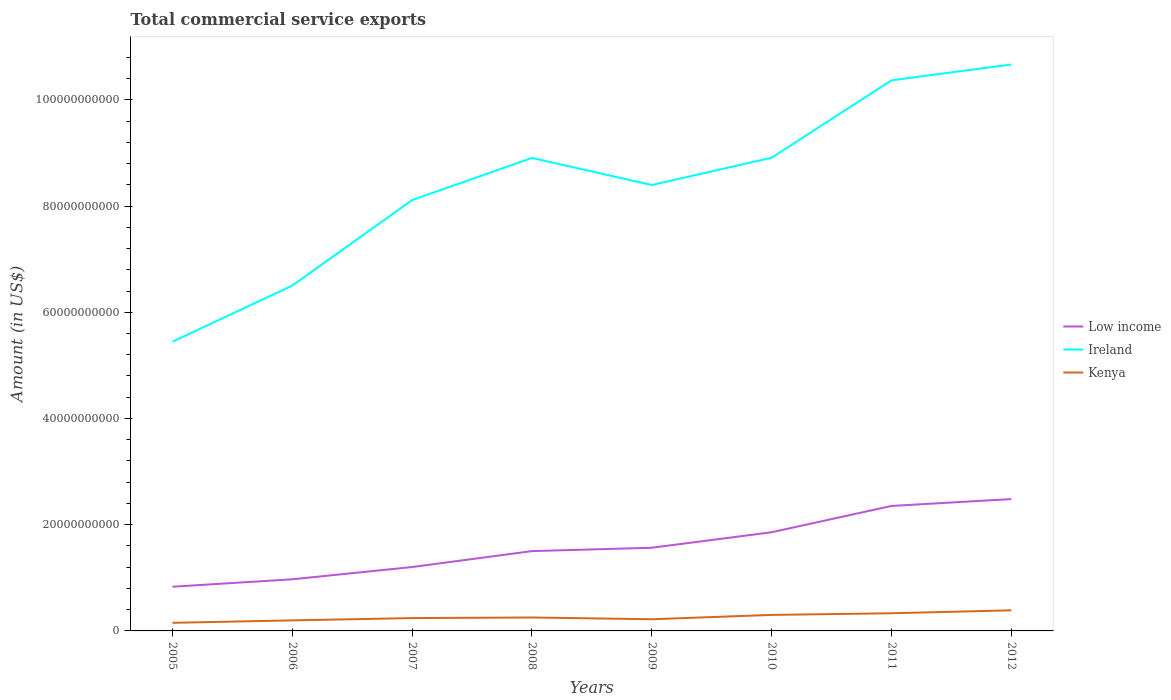Is the number of lines equal to the number of legend labels?
Your response must be concise. Yes. Across all years, what is the maximum total commercial service exports in Ireland?
Your answer should be very brief. 5.45e+1. What is the total total commercial service exports in Kenya in the graph?
Provide a succinct answer. -1.35e+09. What is the difference between the highest and the second highest total commercial service exports in Kenya?
Ensure brevity in your answer.  2.35e+09. Is the total commercial service exports in Low income strictly greater than the total commercial service exports in Ireland over the years?
Provide a succinct answer. Yes. How many lines are there?
Offer a very short reply. 3. What is the difference between two consecutive major ticks on the Y-axis?
Your answer should be very brief. 2.00e+1. Are the values on the major ticks of Y-axis written in scientific E-notation?
Provide a short and direct response. No. Does the graph contain any zero values?
Offer a terse response. No. Does the graph contain grids?
Your answer should be compact. No. Where does the legend appear in the graph?
Provide a succinct answer. Center right. What is the title of the graph?
Offer a terse response. Total commercial service exports. What is the Amount (in US$) of Low income in 2005?
Give a very brief answer. 8.32e+09. What is the Amount (in US$) of Ireland in 2005?
Your response must be concise. 5.45e+1. What is the Amount (in US$) of Kenya in 2005?
Make the answer very short. 1.53e+09. What is the Amount (in US$) of Low income in 2006?
Make the answer very short. 9.72e+09. What is the Amount (in US$) in Ireland in 2006?
Provide a succinct answer. 6.50e+1. What is the Amount (in US$) of Kenya in 2006?
Your answer should be compact. 1.99e+09. What is the Amount (in US$) in Low income in 2007?
Your answer should be compact. 1.20e+1. What is the Amount (in US$) of Ireland in 2007?
Your response must be concise. 8.11e+1. What is the Amount (in US$) in Kenya in 2007?
Make the answer very short. 2.42e+09. What is the Amount (in US$) in Low income in 2008?
Provide a short and direct response. 1.50e+1. What is the Amount (in US$) of Ireland in 2008?
Your answer should be very brief. 8.91e+1. What is the Amount (in US$) in Kenya in 2008?
Your answer should be compact. 2.53e+09. What is the Amount (in US$) in Low income in 2009?
Ensure brevity in your answer.  1.57e+1. What is the Amount (in US$) of Ireland in 2009?
Ensure brevity in your answer.  8.40e+1. What is the Amount (in US$) in Kenya in 2009?
Ensure brevity in your answer.  2.20e+09. What is the Amount (in US$) in Low income in 2010?
Offer a very short reply. 1.86e+1. What is the Amount (in US$) in Ireland in 2010?
Ensure brevity in your answer.  8.91e+1. What is the Amount (in US$) in Kenya in 2010?
Provide a succinct answer. 3.02e+09. What is the Amount (in US$) of Low income in 2011?
Provide a short and direct response. 2.35e+1. What is the Amount (in US$) in Ireland in 2011?
Your response must be concise. 1.04e+11. What is the Amount (in US$) in Kenya in 2011?
Offer a terse response. 3.33e+09. What is the Amount (in US$) of Low income in 2012?
Make the answer very short. 2.48e+1. What is the Amount (in US$) of Ireland in 2012?
Ensure brevity in your answer.  1.07e+11. What is the Amount (in US$) in Kenya in 2012?
Make the answer very short. 3.88e+09. Across all years, what is the maximum Amount (in US$) of Low income?
Make the answer very short. 2.48e+1. Across all years, what is the maximum Amount (in US$) of Ireland?
Your answer should be compact. 1.07e+11. Across all years, what is the maximum Amount (in US$) of Kenya?
Give a very brief answer. 3.88e+09. Across all years, what is the minimum Amount (in US$) in Low income?
Provide a short and direct response. 8.32e+09. Across all years, what is the minimum Amount (in US$) in Ireland?
Offer a very short reply. 5.45e+1. Across all years, what is the minimum Amount (in US$) in Kenya?
Provide a succinct answer. 1.53e+09. What is the total Amount (in US$) in Low income in the graph?
Your answer should be very brief. 1.28e+11. What is the total Amount (in US$) in Ireland in the graph?
Your answer should be very brief. 6.73e+11. What is the total Amount (in US$) of Kenya in the graph?
Your answer should be very brief. 2.09e+1. What is the difference between the Amount (in US$) of Low income in 2005 and that in 2006?
Provide a succinct answer. -1.40e+09. What is the difference between the Amount (in US$) in Ireland in 2005 and that in 2006?
Keep it short and to the point. -1.06e+1. What is the difference between the Amount (in US$) in Kenya in 2005 and that in 2006?
Ensure brevity in your answer.  -4.61e+08. What is the difference between the Amount (in US$) of Low income in 2005 and that in 2007?
Give a very brief answer. -3.71e+09. What is the difference between the Amount (in US$) in Ireland in 2005 and that in 2007?
Your answer should be very brief. -2.67e+1. What is the difference between the Amount (in US$) in Kenya in 2005 and that in 2007?
Your answer should be very brief. -8.92e+08. What is the difference between the Amount (in US$) in Low income in 2005 and that in 2008?
Your answer should be compact. -6.71e+09. What is the difference between the Amount (in US$) of Ireland in 2005 and that in 2008?
Ensure brevity in your answer.  -3.46e+1. What is the difference between the Amount (in US$) in Kenya in 2005 and that in 2008?
Keep it short and to the point. -1.01e+09. What is the difference between the Amount (in US$) of Low income in 2005 and that in 2009?
Your answer should be compact. -7.34e+09. What is the difference between the Amount (in US$) of Ireland in 2005 and that in 2009?
Provide a succinct answer. -2.95e+1. What is the difference between the Amount (in US$) in Kenya in 2005 and that in 2009?
Keep it short and to the point. -6.73e+08. What is the difference between the Amount (in US$) in Low income in 2005 and that in 2010?
Keep it short and to the point. -1.03e+1. What is the difference between the Amount (in US$) in Ireland in 2005 and that in 2010?
Ensure brevity in your answer.  -3.46e+1. What is the difference between the Amount (in US$) of Kenya in 2005 and that in 2010?
Offer a terse response. -1.49e+09. What is the difference between the Amount (in US$) in Low income in 2005 and that in 2011?
Provide a succinct answer. -1.52e+1. What is the difference between the Amount (in US$) of Ireland in 2005 and that in 2011?
Ensure brevity in your answer.  -4.92e+1. What is the difference between the Amount (in US$) of Kenya in 2005 and that in 2011?
Give a very brief answer. -1.80e+09. What is the difference between the Amount (in US$) of Low income in 2005 and that in 2012?
Keep it short and to the point. -1.65e+1. What is the difference between the Amount (in US$) of Ireland in 2005 and that in 2012?
Provide a succinct answer. -5.22e+1. What is the difference between the Amount (in US$) in Kenya in 2005 and that in 2012?
Provide a succinct answer. -2.35e+09. What is the difference between the Amount (in US$) in Low income in 2006 and that in 2007?
Make the answer very short. -2.31e+09. What is the difference between the Amount (in US$) in Ireland in 2006 and that in 2007?
Provide a succinct answer. -1.61e+1. What is the difference between the Amount (in US$) in Kenya in 2006 and that in 2007?
Provide a succinct answer. -4.31e+08. What is the difference between the Amount (in US$) in Low income in 2006 and that in 2008?
Your answer should be compact. -5.31e+09. What is the difference between the Amount (in US$) in Ireland in 2006 and that in 2008?
Your response must be concise. -2.40e+1. What is the difference between the Amount (in US$) of Kenya in 2006 and that in 2008?
Your answer should be compact. -5.44e+08. What is the difference between the Amount (in US$) in Low income in 2006 and that in 2009?
Give a very brief answer. -5.94e+09. What is the difference between the Amount (in US$) in Ireland in 2006 and that in 2009?
Make the answer very short. -1.89e+1. What is the difference between the Amount (in US$) of Kenya in 2006 and that in 2009?
Provide a succinct answer. -2.11e+08. What is the difference between the Amount (in US$) in Low income in 2006 and that in 2010?
Provide a short and direct response. -8.86e+09. What is the difference between the Amount (in US$) in Ireland in 2006 and that in 2010?
Make the answer very short. -2.41e+1. What is the difference between the Amount (in US$) in Kenya in 2006 and that in 2010?
Offer a very short reply. -1.03e+09. What is the difference between the Amount (in US$) in Low income in 2006 and that in 2011?
Give a very brief answer. -1.38e+1. What is the difference between the Amount (in US$) in Ireland in 2006 and that in 2011?
Offer a very short reply. -3.86e+1. What is the difference between the Amount (in US$) of Kenya in 2006 and that in 2011?
Your response must be concise. -1.34e+09. What is the difference between the Amount (in US$) in Low income in 2006 and that in 2012?
Ensure brevity in your answer.  -1.51e+1. What is the difference between the Amount (in US$) in Ireland in 2006 and that in 2012?
Make the answer very short. -4.16e+1. What is the difference between the Amount (in US$) of Kenya in 2006 and that in 2012?
Ensure brevity in your answer.  -1.89e+09. What is the difference between the Amount (in US$) of Low income in 2007 and that in 2008?
Your response must be concise. -3.00e+09. What is the difference between the Amount (in US$) of Ireland in 2007 and that in 2008?
Your response must be concise. -7.94e+09. What is the difference between the Amount (in US$) in Kenya in 2007 and that in 2008?
Your response must be concise. -1.13e+08. What is the difference between the Amount (in US$) of Low income in 2007 and that in 2009?
Offer a very short reply. -3.63e+09. What is the difference between the Amount (in US$) in Ireland in 2007 and that in 2009?
Offer a very short reply. -2.84e+09. What is the difference between the Amount (in US$) of Kenya in 2007 and that in 2009?
Offer a terse response. 2.20e+08. What is the difference between the Amount (in US$) in Low income in 2007 and that in 2010?
Your answer should be compact. -6.55e+09. What is the difference between the Amount (in US$) in Ireland in 2007 and that in 2010?
Make the answer very short. -7.97e+09. What is the difference between the Amount (in US$) in Kenya in 2007 and that in 2010?
Your answer should be very brief. -5.99e+08. What is the difference between the Amount (in US$) in Low income in 2007 and that in 2011?
Your response must be concise. -1.15e+1. What is the difference between the Amount (in US$) of Ireland in 2007 and that in 2011?
Provide a short and direct response. -2.26e+1. What is the difference between the Amount (in US$) in Kenya in 2007 and that in 2011?
Your answer should be compact. -9.08e+08. What is the difference between the Amount (in US$) of Low income in 2007 and that in 2012?
Offer a very short reply. -1.28e+1. What is the difference between the Amount (in US$) in Ireland in 2007 and that in 2012?
Keep it short and to the point. -2.55e+1. What is the difference between the Amount (in US$) of Kenya in 2007 and that in 2012?
Your answer should be compact. -1.46e+09. What is the difference between the Amount (in US$) in Low income in 2008 and that in 2009?
Give a very brief answer. -6.33e+08. What is the difference between the Amount (in US$) of Ireland in 2008 and that in 2009?
Keep it short and to the point. 5.10e+09. What is the difference between the Amount (in US$) in Kenya in 2008 and that in 2009?
Offer a terse response. 3.33e+08. What is the difference between the Amount (in US$) of Low income in 2008 and that in 2010?
Provide a short and direct response. -3.55e+09. What is the difference between the Amount (in US$) of Ireland in 2008 and that in 2010?
Make the answer very short. -3.44e+07. What is the difference between the Amount (in US$) of Kenya in 2008 and that in 2010?
Offer a very short reply. -4.85e+08. What is the difference between the Amount (in US$) in Low income in 2008 and that in 2011?
Your answer should be very brief. -8.50e+09. What is the difference between the Amount (in US$) of Ireland in 2008 and that in 2011?
Provide a short and direct response. -1.46e+1. What is the difference between the Amount (in US$) of Kenya in 2008 and that in 2011?
Provide a succinct answer. -7.95e+08. What is the difference between the Amount (in US$) in Low income in 2008 and that in 2012?
Ensure brevity in your answer.  -9.80e+09. What is the difference between the Amount (in US$) in Ireland in 2008 and that in 2012?
Keep it short and to the point. -1.76e+1. What is the difference between the Amount (in US$) in Kenya in 2008 and that in 2012?
Your answer should be compact. -1.35e+09. What is the difference between the Amount (in US$) in Low income in 2009 and that in 2010?
Your answer should be compact. -2.92e+09. What is the difference between the Amount (in US$) of Ireland in 2009 and that in 2010?
Provide a succinct answer. -5.14e+09. What is the difference between the Amount (in US$) in Kenya in 2009 and that in 2010?
Your answer should be compact. -8.18e+08. What is the difference between the Amount (in US$) in Low income in 2009 and that in 2011?
Make the answer very short. -7.87e+09. What is the difference between the Amount (in US$) of Ireland in 2009 and that in 2011?
Offer a very short reply. -1.97e+1. What is the difference between the Amount (in US$) in Kenya in 2009 and that in 2011?
Your response must be concise. -1.13e+09. What is the difference between the Amount (in US$) of Low income in 2009 and that in 2012?
Your answer should be very brief. -9.16e+09. What is the difference between the Amount (in US$) in Ireland in 2009 and that in 2012?
Give a very brief answer. -2.27e+1. What is the difference between the Amount (in US$) in Kenya in 2009 and that in 2012?
Your response must be concise. -1.68e+09. What is the difference between the Amount (in US$) of Low income in 2010 and that in 2011?
Give a very brief answer. -4.95e+09. What is the difference between the Amount (in US$) in Ireland in 2010 and that in 2011?
Make the answer very short. -1.46e+1. What is the difference between the Amount (in US$) of Kenya in 2010 and that in 2011?
Your answer should be very brief. -3.09e+08. What is the difference between the Amount (in US$) in Low income in 2010 and that in 2012?
Offer a terse response. -6.25e+09. What is the difference between the Amount (in US$) in Ireland in 2010 and that in 2012?
Keep it short and to the point. -1.76e+1. What is the difference between the Amount (in US$) of Kenya in 2010 and that in 2012?
Offer a very short reply. -8.64e+08. What is the difference between the Amount (in US$) of Low income in 2011 and that in 2012?
Your response must be concise. -1.29e+09. What is the difference between the Amount (in US$) of Ireland in 2011 and that in 2012?
Give a very brief answer. -2.98e+09. What is the difference between the Amount (in US$) in Kenya in 2011 and that in 2012?
Ensure brevity in your answer.  -5.54e+08. What is the difference between the Amount (in US$) of Low income in 2005 and the Amount (in US$) of Ireland in 2006?
Offer a very short reply. -5.67e+1. What is the difference between the Amount (in US$) in Low income in 2005 and the Amount (in US$) in Kenya in 2006?
Give a very brief answer. 6.34e+09. What is the difference between the Amount (in US$) in Ireland in 2005 and the Amount (in US$) in Kenya in 2006?
Make the answer very short. 5.25e+1. What is the difference between the Amount (in US$) of Low income in 2005 and the Amount (in US$) of Ireland in 2007?
Provide a succinct answer. -7.28e+1. What is the difference between the Amount (in US$) in Low income in 2005 and the Amount (in US$) in Kenya in 2007?
Your response must be concise. 5.90e+09. What is the difference between the Amount (in US$) in Ireland in 2005 and the Amount (in US$) in Kenya in 2007?
Make the answer very short. 5.20e+1. What is the difference between the Amount (in US$) of Low income in 2005 and the Amount (in US$) of Ireland in 2008?
Offer a very short reply. -8.07e+1. What is the difference between the Amount (in US$) of Low income in 2005 and the Amount (in US$) of Kenya in 2008?
Your answer should be very brief. 5.79e+09. What is the difference between the Amount (in US$) of Ireland in 2005 and the Amount (in US$) of Kenya in 2008?
Your answer should be very brief. 5.19e+1. What is the difference between the Amount (in US$) of Low income in 2005 and the Amount (in US$) of Ireland in 2009?
Your answer should be compact. -7.56e+1. What is the difference between the Amount (in US$) in Low income in 2005 and the Amount (in US$) in Kenya in 2009?
Keep it short and to the point. 6.12e+09. What is the difference between the Amount (in US$) of Ireland in 2005 and the Amount (in US$) of Kenya in 2009?
Give a very brief answer. 5.23e+1. What is the difference between the Amount (in US$) of Low income in 2005 and the Amount (in US$) of Ireland in 2010?
Provide a succinct answer. -8.08e+1. What is the difference between the Amount (in US$) of Low income in 2005 and the Amount (in US$) of Kenya in 2010?
Keep it short and to the point. 5.31e+09. What is the difference between the Amount (in US$) of Ireland in 2005 and the Amount (in US$) of Kenya in 2010?
Your response must be concise. 5.14e+1. What is the difference between the Amount (in US$) in Low income in 2005 and the Amount (in US$) in Ireland in 2011?
Keep it short and to the point. -9.54e+1. What is the difference between the Amount (in US$) in Low income in 2005 and the Amount (in US$) in Kenya in 2011?
Your answer should be compact. 5.00e+09. What is the difference between the Amount (in US$) of Ireland in 2005 and the Amount (in US$) of Kenya in 2011?
Your answer should be compact. 5.11e+1. What is the difference between the Amount (in US$) of Low income in 2005 and the Amount (in US$) of Ireland in 2012?
Keep it short and to the point. -9.83e+1. What is the difference between the Amount (in US$) in Low income in 2005 and the Amount (in US$) in Kenya in 2012?
Your response must be concise. 4.44e+09. What is the difference between the Amount (in US$) in Ireland in 2005 and the Amount (in US$) in Kenya in 2012?
Make the answer very short. 5.06e+1. What is the difference between the Amount (in US$) of Low income in 2006 and the Amount (in US$) of Ireland in 2007?
Provide a short and direct response. -7.14e+1. What is the difference between the Amount (in US$) of Low income in 2006 and the Amount (in US$) of Kenya in 2007?
Offer a terse response. 7.30e+09. What is the difference between the Amount (in US$) of Ireland in 2006 and the Amount (in US$) of Kenya in 2007?
Make the answer very short. 6.26e+1. What is the difference between the Amount (in US$) in Low income in 2006 and the Amount (in US$) in Ireland in 2008?
Give a very brief answer. -7.93e+1. What is the difference between the Amount (in US$) of Low income in 2006 and the Amount (in US$) of Kenya in 2008?
Provide a short and direct response. 7.19e+09. What is the difference between the Amount (in US$) in Ireland in 2006 and the Amount (in US$) in Kenya in 2008?
Ensure brevity in your answer.  6.25e+1. What is the difference between the Amount (in US$) of Low income in 2006 and the Amount (in US$) of Ireland in 2009?
Your answer should be very brief. -7.42e+1. What is the difference between the Amount (in US$) of Low income in 2006 and the Amount (in US$) of Kenya in 2009?
Your answer should be very brief. 7.52e+09. What is the difference between the Amount (in US$) of Ireland in 2006 and the Amount (in US$) of Kenya in 2009?
Keep it short and to the point. 6.28e+1. What is the difference between the Amount (in US$) of Low income in 2006 and the Amount (in US$) of Ireland in 2010?
Ensure brevity in your answer.  -7.94e+1. What is the difference between the Amount (in US$) of Low income in 2006 and the Amount (in US$) of Kenya in 2010?
Make the answer very short. 6.70e+09. What is the difference between the Amount (in US$) of Ireland in 2006 and the Amount (in US$) of Kenya in 2010?
Ensure brevity in your answer.  6.20e+1. What is the difference between the Amount (in US$) of Low income in 2006 and the Amount (in US$) of Ireland in 2011?
Offer a very short reply. -9.40e+1. What is the difference between the Amount (in US$) in Low income in 2006 and the Amount (in US$) in Kenya in 2011?
Make the answer very short. 6.40e+09. What is the difference between the Amount (in US$) in Ireland in 2006 and the Amount (in US$) in Kenya in 2011?
Your answer should be very brief. 6.17e+1. What is the difference between the Amount (in US$) of Low income in 2006 and the Amount (in US$) of Ireland in 2012?
Offer a terse response. -9.69e+1. What is the difference between the Amount (in US$) of Low income in 2006 and the Amount (in US$) of Kenya in 2012?
Make the answer very short. 5.84e+09. What is the difference between the Amount (in US$) in Ireland in 2006 and the Amount (in US$) in Kenya in 2012?
Provide a succinct answer. 6.11e+1. What is the difference between the Amount (in US$) in Low income in 2007 and the Amount (in US$) in Ireland in 2008?
Make the answer very short. -7.70e+1. What is the difference between the Amount (in US$) of Low income in 2007 and the Amount (in US$) of Kenya in 2008?
Ensure brevity in your answer.  9.50e+09. What is the difference between the Amount (in US$) of Ireland in 2007 and the Amount (in US$) of Kenya in 2008?
Your response must be concise. 7.86e+1. What is the difference between the Amount (in US$) in Low income in 2007 and the Amount (in US$) in Ireland in 2009?
Keep it short and to the point. -7.19e+1. What is the difference between the Amount (in US$) in Low income in 2007 and the Amount (in US$) in Kenya in 2009?
Provide a short and direct response. 9.83e+09. What is the difference between the Amount (in US$) in Ireland in 2007 and the Amount (in US$) in Kenya in 2009?
Make the answer very short. 7.89e+1. What is the difference between the Amount (in US$) of Low income in 2007 and the Amount (in US$) of Ireland in 2010?
Your answer should be very brief. -7.71e+1. What is the difference between the Amount (in US$) in Low income in 2007 and the Amount (in US$) in Kenya in 2010?
Make the answer very short. 9.01e+09. What is the difference between the Amount (in US$) in Ireland in 2007 and the Amount (in US$) in Kenya in 2010?
Offer a very short reply. 7.81e+1. What is the difference between the Amount (in US$) in Low income in 2007 and the Amount (in US$) in Ireland in 2011?
Give a very brief answer. -9.16e+1. What is the difference between the Amount (in US$) in Low income in 2007 and the Amount (in US$) in Kenya in 2011?
Offer a terse response. 8.71e+09. What is the difference between the Amount (in US$) of Ireland in 2007 and the Amount (in US$) of Kenya in 2011?
Your answer should be very brief. 7.78e+1. What is the difference between the Amount (in US$) in Low income in 2007 and the Amount (in US$) in Ireland in 2012?
Your response must be concise. -9.46e+1. What is the difference between the Amount (in US$) in Low income in 2007 and the Amount (in US$) in Kenya in 2012?
Keep it short and to the point. 8.15e+09. What is the difference between the Amount (in US$) of Ireland in 2007 and the Amount (in US$) of Kenya in 2012?
Keep it short and to the point. 7.72e+1. What is the difference between the Amount (in US$) of Low income in 2008 and the Amount (in US$) of Ireland in 2009?
Provide a short and direct response. -6.89e+1. What is the difference between the Amount (in US$) of Low income in 2008 and the Amount (in US$) of Kenya in 2009?
Offer a very short reply. 1.28e+1. What is the difference between the Amount (in US$) of Ireland in 2008 and the Amount (in US$) of Kenya in 2009?
Provide a short and direct response. 8.69e+1. What is the difference between the Amount (in US$) in Low income in 2008 and the Amount (in US$) in Ireland in 2010?
Offer a terse response. -7.41e+1. What is the difference between the Amount (in US$) in Low income in 2008 and the Amount (in US$) in Kenya in 2010?
Your response must be concise. 1.20e+1. What is the difference between the Amount (in US$) of Ireland in 2008 and the Amount (in US$) of Kenya in 2010?
Make the answer very short. 8.60e+1. What is the difference between the Amount (in US$) of Low income in 2008 and the Amount (in US$) of Ireland in 2011?
Your answer should be compact. -8.86e+1. What is the difference between the Amount (in US$) in Low income in 2008 and the Amount (in US$) in Kenya in 2011?
Ensure brevity in your answer.  1.17e+1. What is the difference between the Amount (in US$) of Ireland in 2008 and the Amount (in US$) of Kenya in 2011?
Your answer should be very brief. 8.57e+1. What is the difference between the Amount (in US$) in Low income in 2008 and the Amount (in US$) in Ireland in 2012?
Your answer should be compact. -9.16e+1. What is the difference between the Amount (in US$) of Low income in 2008 and the Amount (in US$) of Kenya in 2012?
Ensure brevity in your answer.  1.11e+1. What is the difference between the Amount (in US$) of Ireland in 2008 and the Amount (in US$) of Kenya in 2012?
Provide a succinct answer. 8.52e+1. What is the difference between the Amount (in US$) of Low income in 2009 and the Amount (in US$) of Ireland in 2010?
Make the answer very short. -7.34e+1. What is the difference between the Amount (in US$) of Low income in 2009 and the Amount (in US$) of Kenya in 2010?
Offer a terse response. 1.26e+1. What is the difference between the Amount (in US$) of Ireland in 2009 and the Amount (in US$) of Kenya in 2010?
Your response must be concise. 8.09e+1. What is the difference between the Amount (in US$) in Low income in 2009 and the Amount (in US$) in Ireland in 2011?
Provide a short and direct response. -8.80e+1. What is the difference between the Amount (in US$) of Low income in 2009 and the Amount (in US$) of Kenya in 2011?
Make the answer very short. 1.23e+1. What is the difference between the Amount (in US$) in Ireland in 2009 and the Amount (in US$) in Kenya in 2011?
Offer a very short reply. 8.06e+1. What is the difference between the Amount (in US$) of Low income in 2009 and the Amount (in US$) of Ireland in 2012?
Provide a short and direct response. -9.10e+1. What is the difference between the Amount (in US$) in Low income in 2009 and the Amount (in US$) in Kenya in 2012?
Offer a very short reply. 1.18e+1. What is the difference between the Amount (in US$) in Ireland in 2009 and the Amount (in US$) in Kenya in 2012?
Your response must be concise. 8.01e+1. What is the difference between the Amount (in US$) of Low income in 2010 and the Amount (in US$) of Ireland in 2011?
Your response must be concise. -8.51e+1. What is the difference between the Amount (in US$) in Low income in 2010 and the Amount (in US$) in Kenya in 2011?
Your answer should be compact. 1.53e+1. What is the difference between the Amount (in US$) of Ireland in 2010 and the Amount (in US$) of Kenya in 2011?
Your answer should be very brief. 8.58e+1. What is the difference between the Amount (in US$) of Low income in 2010 and the Amount (in US$) of Ireland in 2012?
Your answer should be compact. -8.81e+1. What is the difference between the Amount (in US$) in Low income in 2010 and the Amount (in US$) in Kenya in 2012?
Your answer should be compact. 1.47e+1. What is the difference between the Amount (in US$) in Ireland in 2010 and the Amount (in US$) in Kenya in 2012?
Offer a very short reply. 8.52e+1. What is the difference between the Amount (in US$) in Low income in 2011 and the Amount (in US$) in Ireland in 2012?
Ensure brevity in your answer.  -8.31e+1. What is the difference between the Amount (in US$) in Low income in 2011 and the Amount (in US$) in Kenya in 2012?
Offer a terse response. 1.97e+1. What is the difference between the Amount (in US$) in Ireland in 2011 and the Amount (in US$) in Kenya in 2012?
Your answer should be compact. 9.98e+1. What is the average Amount (in US$) of Low income per year?
Provide a short and direct response. 1.60e+1. What is the average Amount (in US$) in Ireland per year?
Offer a very short reply. 8.41e+1. What is the average Amount (in US$) in Kenya per year?
Your answer should be very brief. 2.61e+09. In the year 2005, what is the difference between the Amount (in US$) of Low income and Amount (in US$) of Ireland?
Offer a very short reply. -4.61e+1. In the year 2005, what is the difference between the Amount (in US$) in Low income and Amount (in US$) in Kenya?
Give a very brief answer. 6.80e+09. In the year 2005, what is the difference between the Amount (in US$) of Ireland and Amount (in US$) of Kenya?
Provide a succinct answer. 5.29e+1. In the year 2006, what is the difference between the Amount (in US$) of Low income and Amount (in US$) of Ireland?
Give a very brief answer. -5.53e+1. In the year 2006, what is the difference between the Amount (in US$) in Low income and Amount (in US$) in Kenya?
Provide a succinct answer. 7.73e+09. In the year 2006, what is the difference between the Amount (in US$) of Ireland and Amount (in US$) of Kenya?
Offer a terse response. 6.30e+1. In the year 2007, what is the difference between the Amount (in US$) in Low income and Amount (in US$) in Ireland?
Offer a very short reply. -6.91e+1. In the year 2007, what is the difference between the Amount (in US$) of Low income and Amount (in US$) of Kenya?
Keep it short and to the point. 9.61e+09. In the year 2007, what is the difference between the Amount (in US$) in Ireland and Amount (in US$) in Kenya?
Provide a short and direct response. 7.87e+1. In the year 2008, what is the difference between the Amount (in US$) of Low income and Amount (in US$) of Ireland?
Offer a very short reply. -7.40e+1. In the year 2008, what is the difference between the Amount (in US$) of Low income and Amount (in US$) of Kenya?
Your answer should be compact. 1.25e+1. In the year 2008, what is the difference between the Amount (in US$) of Ireland and Amount (in US$) of Kenya?
Your response must be concise. 8.65e+1. In the year 2009, what is the difference between the Amount (in US$) in Low income and Amount (in US$) in Ireland?
Keep it short and to the point. -6.83e+1. In the year 2009, what is the difference between the Amount (in US$) in Low income and Amount (in US$) in Kenya?
Keep it short and to the point. 1.35e+1. In the year 2009, what is the difference between the Amount (in US$) in Ireland and Amount (in US$) in Kenya?
Your answer should be very brief. 8.18e+1. In the year 2010, what is the difference between the Amount (in US$) of Low income and Amount (in US$) of Ireland?
Make the answer very short. -7.05e+1. In the year 2010, what is the difference between the Amount (in US$) of Low income and Amount (in US$) of Kenya?
Your answer should be very brief. 1.56e+1. In the year 2010, what is the difference between the Amount (in US$) in Ireland and Amount (in US$) in Kenya?
Give a very brief answer. 8.61e+1. In the year 2011, what is the difference between the Amount (in US$) in Low income and Amount (in US$) in Ireland?
Offer a very short reply. -8.01e+1. In the year 2011, what is the difference between the Amount (in US$) in Low income and Amount (in US$) in Kenya?
Keep it short and to the point. 2.02e+1. In the year 2011, what is the difference between the Amount (in US$) in Ireland and Amount (in US$) in Kenya?
Provide a short and direct response. 1.00e+11. In the year 2012, what is the difference between the Amount (in US$) of Low income and Amount (in US$) of Ireland?
Your response must be concise. -8.18e+1. In the year 2012, what is the difference between the Amount (in US$) of Low income and Amount (in US$) of Kenya?
Your answer should be very brief. 2.09e+1. In the year 2012, what is the difference between the Amount (in US$) in Ireland and Amount (in US$) in Kenya?
Keep it short and to the point. 1.03e+11. What is the ratio of the Amount (in US$) in Low income in 2005 to that in 2006?
Your answer should be very brief. 0.86. What is the ratio of the Amount (in US$) in Ireland in 2005 to that in 2006?
Ensure brevity in your answer.  0.84. What is the ratio of the Amount (in US$) in Kenya in 2005 to that in 2006?
Make the answer very short. 0.77. What is the ratio of the Amount (in US$) in Low income in 2005 to that in 2007?
Give a very brief answer. 0.69. What is the ratio of the Amount (in US$) of Ireland in 2005 to that in 2007?
Make the answer very short. 0.67. What is the ratio of the Amount (in US$) of Kenya in 2005 to that in 2007?
Your response must be concise. 0.63. What is the ratio of the Amount (in US$) in Low income in 2005 to that in 2008?
Provide a succinct answer. 0.55. What is the ratio of the Amount (in US$) in Ireland in 2005 to that in 2008?
Your response must be concise. 0.61. What is the ratio of the Amount (in US$) in Kenya in 2005 to that in 2008?
Provide a succinct answer. 0.6. What is the ratio of the Amount (in US$) in Low income in 2005 to that in 2009?
Your answer should be very brief. 0.53. What is the ratio of the Amount (in US$) in Ireland in 2005 to that in 2009?
Your answer should be compact. 0.65. What is the ratio of the Amount (in US$) in Kenya in 2005 to that in 2009?
Your answer should be very brief. 0.69. What is the ratio of the Amount (in US$) of Low income in 2005 to that in 2010?
Ensure brevity in your answer.  0.45. What is the ratio of the Amount (in US$) in Ireland in 2005 to that in 2010?
Provide a succinct answer. 0.61. What is the ratio of the Amount (in US$) of Kenya in 2005 to that in 2010?
Your response must be concise. 0.51. What is the ratio of the Amount (in US$) of Low income in 2005 to that in 2011?
Your answer should be compact. 0.35. What is the ratio of the Amount (in US$) in Ireland in 2005 to that in 2011?
Make the answer very short. 0.53. What is the ratio of the Amount (in US$) in Kenya in 2005 to that in 2011?
Your answer should be compact. 0.46. What is the ratio of the Amount (in US$) in Low income in 2005 to that in 2012?
Your answer should be compact. 0.34. What is the ratio of the Amount (in US$) in Ireland in 2005 to that in 2012?
Give a very brief answer. 0.51. What is the ratio of the Amount (in US$) in Kenya in 2005 to that in 2012?
Your answer should be compact. 0.39. What is the ratio of the Amount (in US$) of Low income in 2006 to that in 2007?
Offer a terse response. 0.81. What is the ratio of the Amount (in US$) in Ireland in 2006 to that in 2007?
Provide a short and direct response. 0.8. What is the ratio of the Amount (in US$) of Kenya in 2006 to that in 2007?
Give a very brief answer. 0.82. What is the ratio of the Amount (in US$) of Low income in 2006 to that in 2008?
Keep it short and to the point. 0.65. What is the ratio of the Amount (in US$) of Ireland in 2006 to that in 2008?
Your answer should be very brief. 0.73. What is the ratio of the Amount (in US$) in Kenya in 2006 to that in 2008?
Provide a succinct answer. 0.78. What is the ratio of the Amount (in US$) in Low income in 2006 to that in 2009?
Your answer should be compact. 0.62. What is the ratio of the Amount (in US$) of Ireland in 2006 to that in 2009?
Provide a short and direct response. 0.77. What is the ratio of the Amount (in US$) of Kenya in 2006 to that in 2009?
Provide a short and direct response. 0.9. What is the ratio of the Amount (in US$) in Low income in 2006 to that in 2010?
Your response must be concise. 0.52. What is the ratio of the Amount (in US$) of Ireland in 2006 to that in 2010?
Your answer should be compact. 0.73. What is the ratio of the Amount (in US$) of Kenya in 2006 to that in 2010?
Provide a succinct answer. 0.66. What is the ratio of the Amount (in US$) of Low income in 2006 to that in 2011?
Provide a succinct answer. 0.41. What is the ratio of the Amount (in US$) in Ireland in 2006 to that in 2011?
Provide a short and direct response. 0.63. What is the ratio of the Amount (in US$) in Kenya in 2006 to that in 2011?
Offer a very short reply. 0.6. What is the ratio of the Amount (in US$) of Low income in 2006 to that in 2012?
Make the answer very short. 0.39. What is the ratio of the Amount (in US$) of Ireland in 2006 to that in 2012?
Your answer should be very brief. 0.61. What is the ratio of the Amount (in US$) of Kenya in 2006 to that in 2012?
Provide a succinct answer. 0.51. What is the ratio of the Amount (in US$) in Low income in 2007 to that in 2008?
Provide a short and direct response. 0.8. What is the ratio of the Amount (in US$) in Ireland in 2007 to that in 2008?
Your answer should be very brief. 0.91. What is the ratio of the Amount (in US$) of Kenya in 2007 to that in 2008?
Offer a very short reply. 0.96. What is the ratio of the Amount (in US$) in Low income in 2007 to that in 2009?
Offer a very short reply. 0.77. What is the ratio of the Amount (in US$) of Ireland in 2007 to that in 2009?
Your answer should be compact. 0.97. What is the ratio of the Amount (in US$) in Kenya in 2007 to that in 2009?
Provide a short and direct response. 1.1. What is the ratio of the Amount (in US$) in Low income in 2007 to that in 2010?
Ensure brevity in your answer.  0.65. What is the ratio of the Amount (in US$) in Ireland in 2007 to that in 2010?
Provide a succinct answer. 0.91. What is the ratio of the Amount (in US$) in Kenya in 2007 to that in 2010?
Keep it short and to the point. 0.8. What is the ratio of the Amount (in US$) in Low income in 2007 to that in 2011?
Provide a short and direct response. 0.51. What is the ratio of the Amount (in US$) of Ireland in 2007 to that in 2011?
Give a very brief answer. 0.78. What is the ratio of the Amount (in US$) of Kenya in 2007 to that in 2011?
Offer a very short reply. 0.73. What is the ratio of the Amount (in US$) in Low income in 2007 to that in 2012?
Provide a succinct answer. 0.48. What is the ratio of the Amount (in US$) in Ireland in 2007 to that in 2012?
Ensure brevity in your answer.  0.76. What is the ratio of the Amount (in US$) in Kenya in 2007 to that in 2012?
Offer a very short reply. 0.62. What is the ratio of the Amount (in US$) of Low income in 2008 to that in 2009?
Make the answer very short. 0.96. What is the ratio of the Amount (in US$) in Ireland in 2008 to that in 2009?
Your answer should be compact. 1.06. What is the ratio of the Amount (in US$) of Kenya in 2008 to that in 2009?
Give a very brief answer. 1.15. What is the ratio of the Amount (in US$) of Low income in 2008 to that in 2010?
Keep it short and to the point. 0.81. What is the ratio of the Amount (in US$) of Ireland in 2008 to that in 2010?
Make the answer very short. 1. What is the ratio of the Amount (in US$) of Kenya in 2008 to that in 2010?
Ensure brevity in your answer.  0.84. What is the ratio of the Amount (in US$) of Low income in 2008 to that in 2011?
Provide a succinct answer. 0.64. What is the ratio of the Amount (in US$) in Ireland in 2008 to that in 2011?
Your answer should be compact. 0.86. What is the ratio of the Amount (in US$) of Kenya in 2008 to that in 2011?
Your answer should be very brief. 0.76. What is the ratio of the Amount (in US$) in Low income in 2008 to that in 2012?
Provide a succinct answer. 0.61. What is the ratio of the Amount (in US$) in Ireland in 2008 to that in 2012?
Offer a very short reply. 0.84. What is the ratio of the Amount (in US$) in Kenya in 2008 to that in 2012?
Your response must be concise. 0.65. What is the ratio of the Amount (in US$) in Low income in 2009 to that in 2010?
Provide a short and direct response. 0.84. What is the ratio of the Amount (in US$) of Ireland in 2009 to that in 2010?
Ensure brevity in your answer.  0.94. What is the ratio of the Amount (in US$) of Kenya in 2009 to that in 2010?
Provide a short and direct response. 0.73. What is the ratio of the Amount (in US$) of Low income in 2009 to that in 2011?
Provide a short and direct response. 0.67. What is the ratio of the Amount (in US$) in Ireland in 2009 to that in 2011?
Keep it short and to the point. 0.81. What is the ratio of the Amount (in US$) in Kenya in 2009 to that in 2011?
Your answer should be very brief. 0.66. What is the ratio of the Amount (in US$) in Low income in 2009 to that in 2012?
Offer a very short reply. 0.63. What is the ratio of the Amount (in US$) of Ireland in 2009 to that in 2012?
Ensure brevity in your answer.  0.79. What is the ratio of the Amount (in US$) in Kenya in 2009 to that in 2012?
Give a very brief answer. 0.57. What is the ratio of the Amount (in US$) in Low income in 2010 to that in 2011?
Your answer should be compact. 0.79. What is the ratio of the Amount (in US$) of Ireland in 2010 to that in 2011?
Make the answer very short. 0.86. What is the ratio of the Amount (in US$) in Kenya in 2010 to that in 2011?
Make the answer very short. 0.91. What is the ratio of the Amount (in US$) of Low income in 2010 to that in 2012?
Provide a succinct answer. 0.75. What is the ratio of the Amount (in US$) in Ireland in 2010 to that in 2012?
Keep it short and to the point. 0.84. What is the ratio of the Amount (in US$) in Kenya in 2010 to that in 2012?
Provide a short and direct response. 0.78. What is the ratio of the Amount (in US$) of Low income in 2011 to that in 2012?
Offer a very short reply. 0.95. What is the ratio of the Amount (in US$) of Ireland in 2011 to that in 2012?
Provide a succinct answer. 0.97. What is the difference between the highest and the second highest Amount (in US$) of Low income?
Your answer should be compact. 1.29e+09. What is the difference between the highest and the second highest Amount (in US$) in Ireland?
Offer a very short reply. 2.98e+09. What is the difference between the highest and the second highest Amount (in US$) in Kenya?
Make the answer very short. 5.54e+08. What is the difference between the highest and the lowest Amount (in US$) of Low income?
Offer a terse response. 1.65e+1. What is the difference between the highest and the lowest Amount (in US$) of Ireland?
Offer a very short reply. 5.22e+1. What is the difference between the highest and the lowest Amount (in US$) in Kenya?
Your answer should be compact. 2.35e+09. 